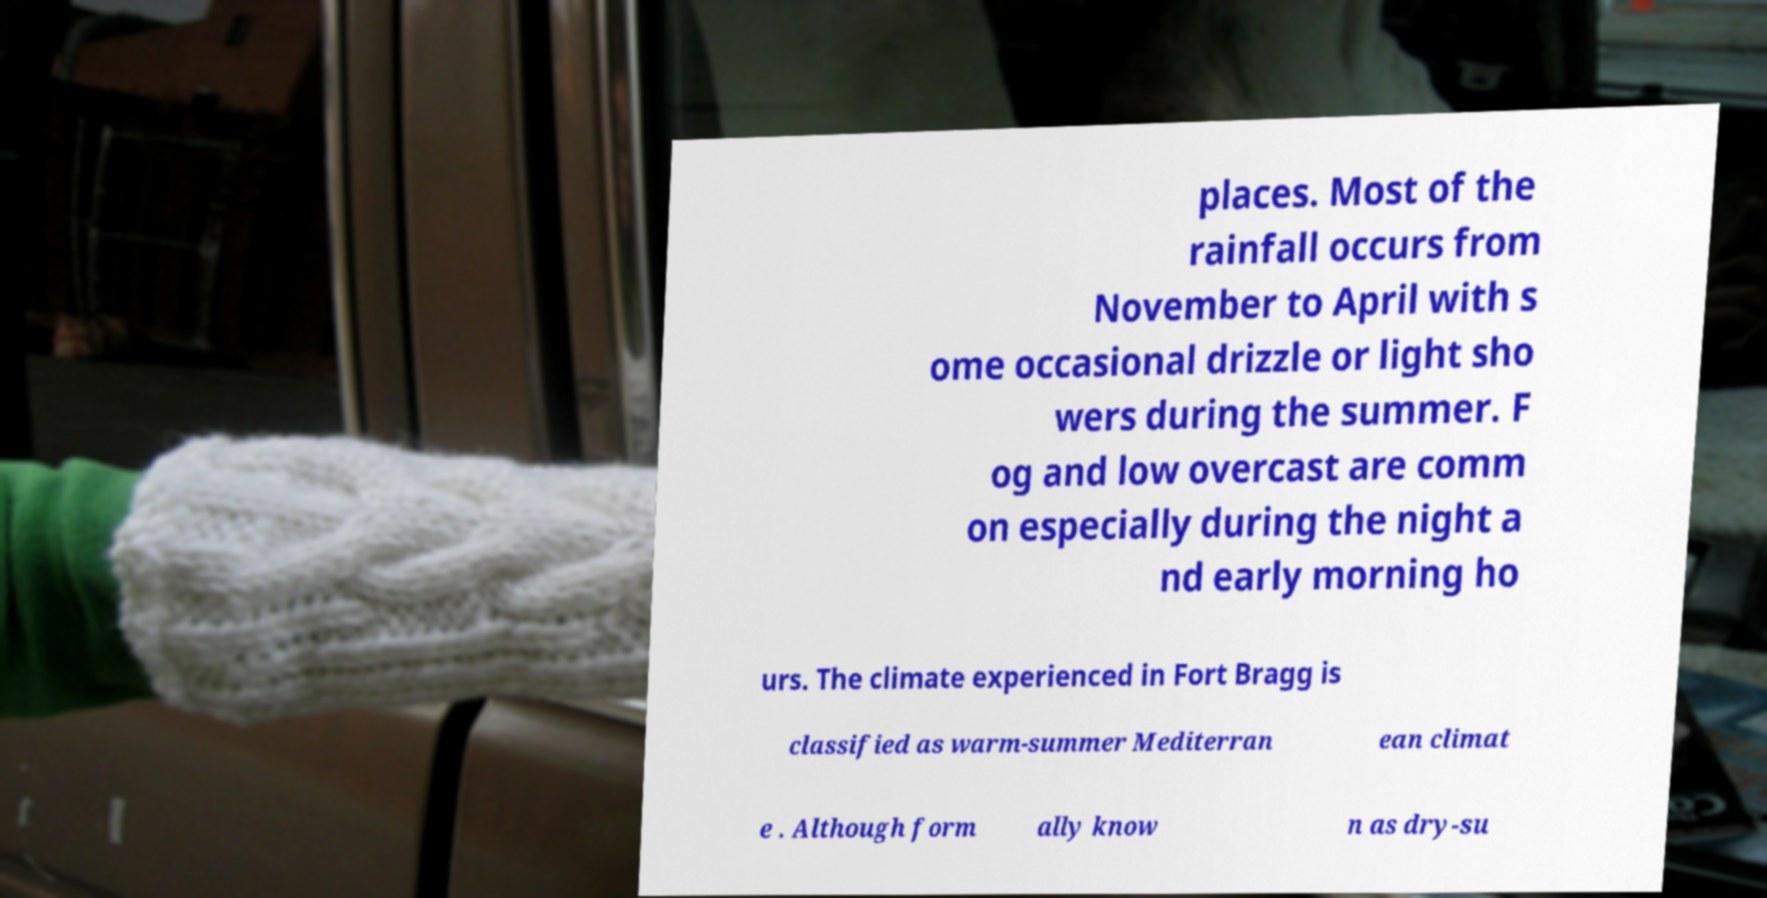Can you read and provide the text displayed in the image?This photo seems to have some interesting text. Can you extract and type it out for me? places. Most of the rainfall occurs from November to April with s ome occasional drizzle or light sho wers during the summer. F og and low overcast are comm on especially during the night a nd early morning ho urs. The climate experienced in Fort Bragg is classified as warm-summer Mediterran ean climat e . Although form ally know n as dry-su 